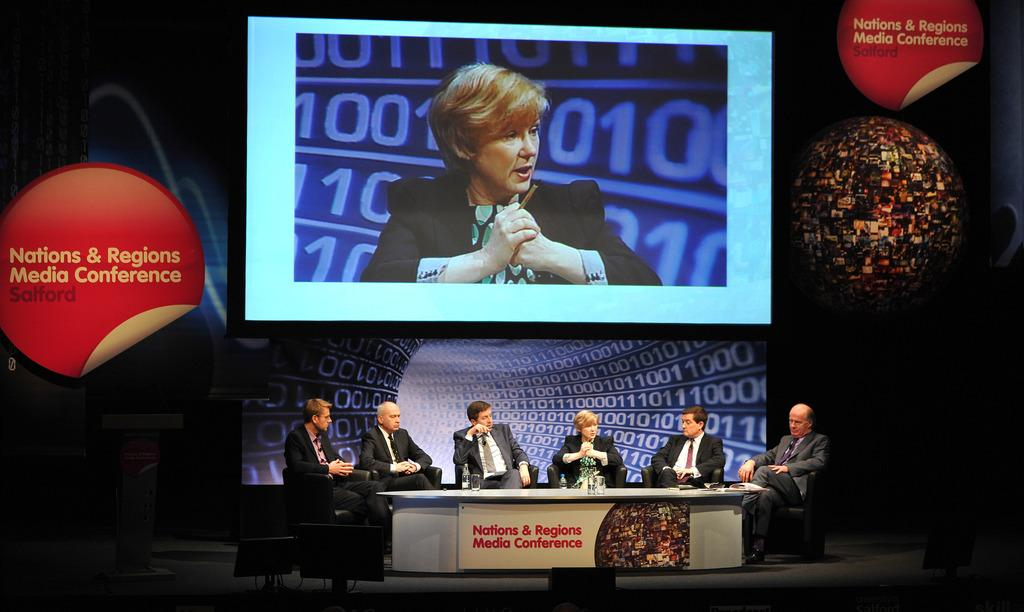<image>
Provide a brief description of the given image. a group of people sitting behind a table that has a front banner that says 'nations & regions media conference' 